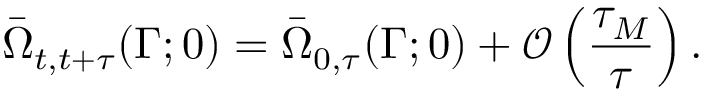<formula> <loc_0><loc_0><loc_500><loc_500>\bar { \Omega } _ { t , t + \tau } ( \Gamma ; 0 ) = \bar { \Omega } _ { 0 , \tau } ( \Gamma ; 0 ) + \mathcal { O } \left ( \frac { \tau _ { M } } { \tau } \right ) .</formula> 